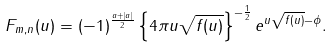<formula> <loc_0><loc_0><loc_500><loc_500>F _ { m , n } ( u ) = ( - 1 ) ^ { \frac { a + | a | } { 2 } } \left \{ 4 \pi u \sqrt { f ( u ) } \right \} ^ { - \frac { 1 } { 2 } } e ^ { u \sqrt { f ( u ) } - \phi } .</formula> 